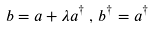<formula> <loc_0><loc_0><loc_500><loc_500>b = a + \lambda a ^ { \dagger } \, , \, b ^ { \dagger } = a ^ { \dagger }</formula> 